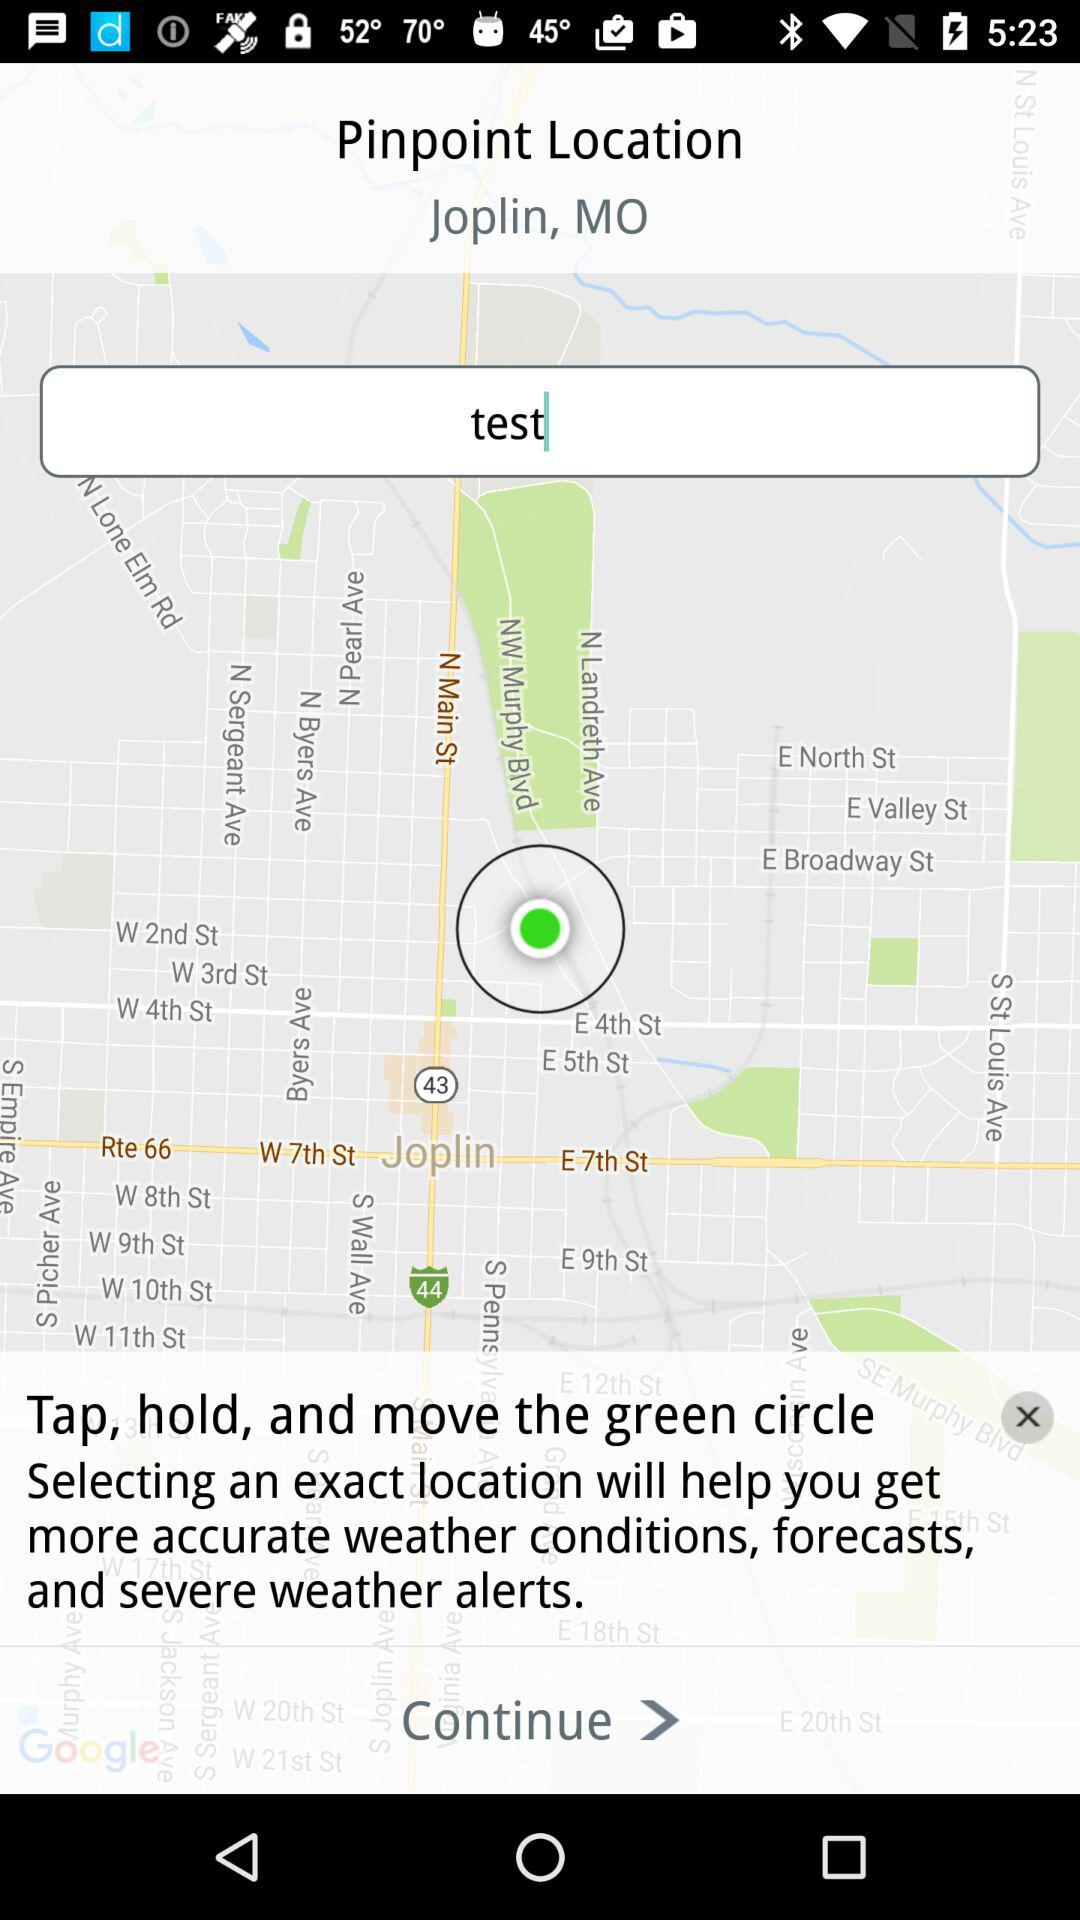What is the pinpoint location? The pinpoint location is Joplin, MO. 